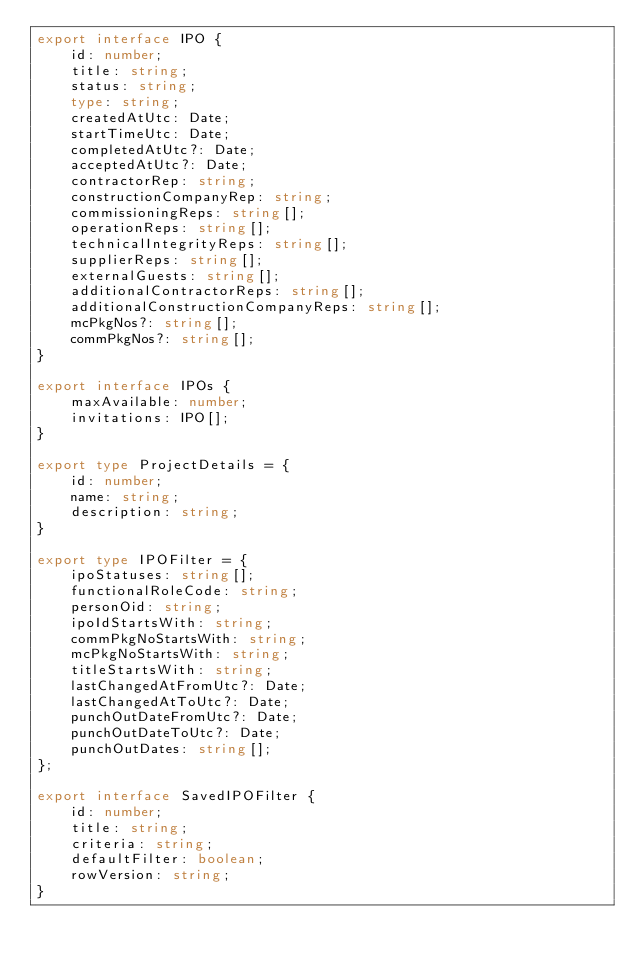Convert code to text. <code><loc_0><loc_0><loc_500><loc_500><_TypeScript_>export interface IPO {
    id: number;
    title: string;
    status: string;
    type: string;
    createdAtUtc: Date;
    startTimeUtc: Date;
    completedAtUtc?: Date;
    acceptedAtUtc?: Date;
    contractorRep: string;
    constructionCompanyRep: string;
    commissioningReps: string[];
    operationReps: string[];
    technicalIntegrityReps: string[];
    supplierReps: string[];
    externalGuests: string[];
    additionalContractorReps: string[];
    additionalConstructionCompanyReps: string[];
    mcPkgNos?: string[];
    commPkgNos?: string[];
}

export interface IPOs {
    maxAvailable: number;
    invitations: IPO[];
}

export type ProjectDetails = {
    id: number;
    name: string;
    description: string;
}

export type IPOFilter = {
    ipoStatuses: string[];
    functionalRoleCode: string;
    personOid: string;
    ipoIdStartsWith: string;
    commPkgNoStartsWith: string;
    mcPkgNoStartsWith: string;
    titleStartsWith: string;
    lastChangedAtFromUtc?: Date;
    lastChangedAtToUtc?: Date;
    punchOutDateFromUtc?: Date;
    punchOutDateToUtc?: Date;
    punchOutDates: string[];
};

export interface SavedIPOFilter {
    id: number;
    title: string;
    criteria: string;
    defaultFilter: boolean;
    rowVersion: string;
}
</code> 